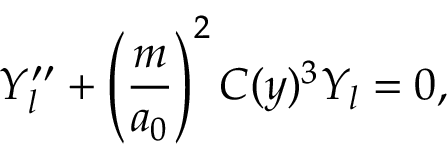<formula> <loc_0><loc_0><loc_500><loc_500>Y _ { l } ^ { \prime \prime } + \left ( \frac { m } { a _ { 0 } } \right ) ^ { 2 } C ( y ) ^ { 3 } Y _ { l } = 0 ,</formula> 